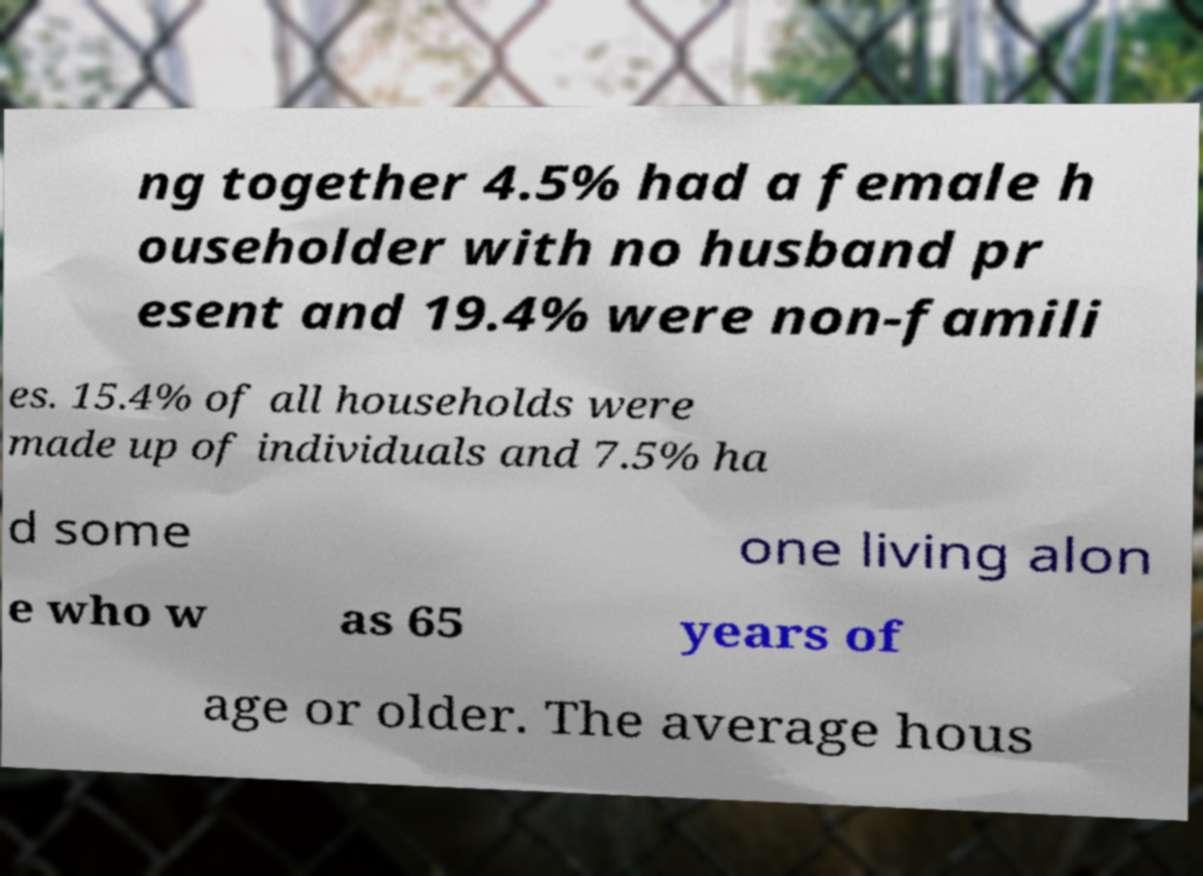For documentation purposes, I need the text within this image transcribed. Could you provide that? ng together 4.5% had a female h ouseholder with no husband pr esent and 19.4% were non-famili es. 15.4% of all households were made up of individuals and 7.5% ha d some one living alon e who w as 65 years of age or older. The average hous 